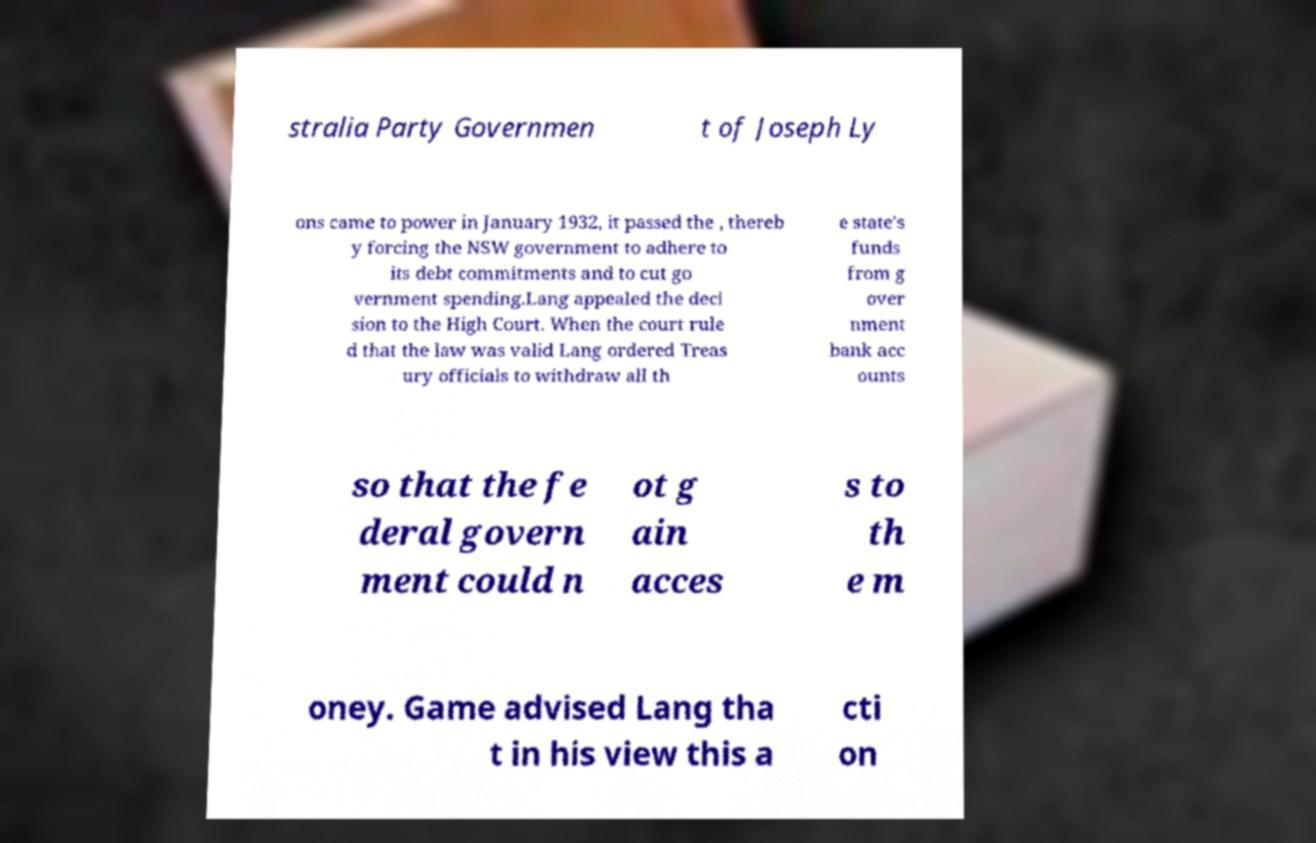Can you accurately transcribe the text from the provided image for me? stralia Party Governmen t of Joseph Ly ons came to power in January 1932, it passed the , thereb y forcing the NSW government to adhere to its debt commitments and to cut go vernment spending.Lang appealed the deci sion to the High Court. When the court rule d that the law was valid Lang ordered Treas ury officials to withdraw all th e state's funds from g over nment bank acc ounts so that the fe deral govern ment could n ot g ain acces s to th e m oney. Game advised Lang tha t in his view this a cti on 